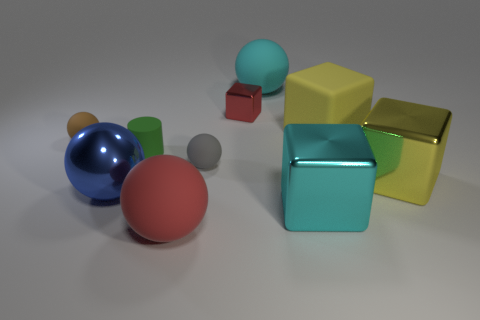Subtract all large blue balls. How many balls are left? 4 Subtract all gray balls. How many balls are left? 4 Subtract 1 cubes. How many cubes are left? 3 Subtract all purple spheres. Subtract all green blocks. How many spheres are left? 5 Subtract all cylinders. How many objects are left? 9 Add 9 green matte cylinders. How many green matte cylinders are left? 10 Add 4 big yellow metal blocks. How many big yellow metal blocks exist? 5 Subtract 0 green balls. How many objects are left? 10 Subtract all yellow objects. Subtract all small gray things. How many objects are left? 7 